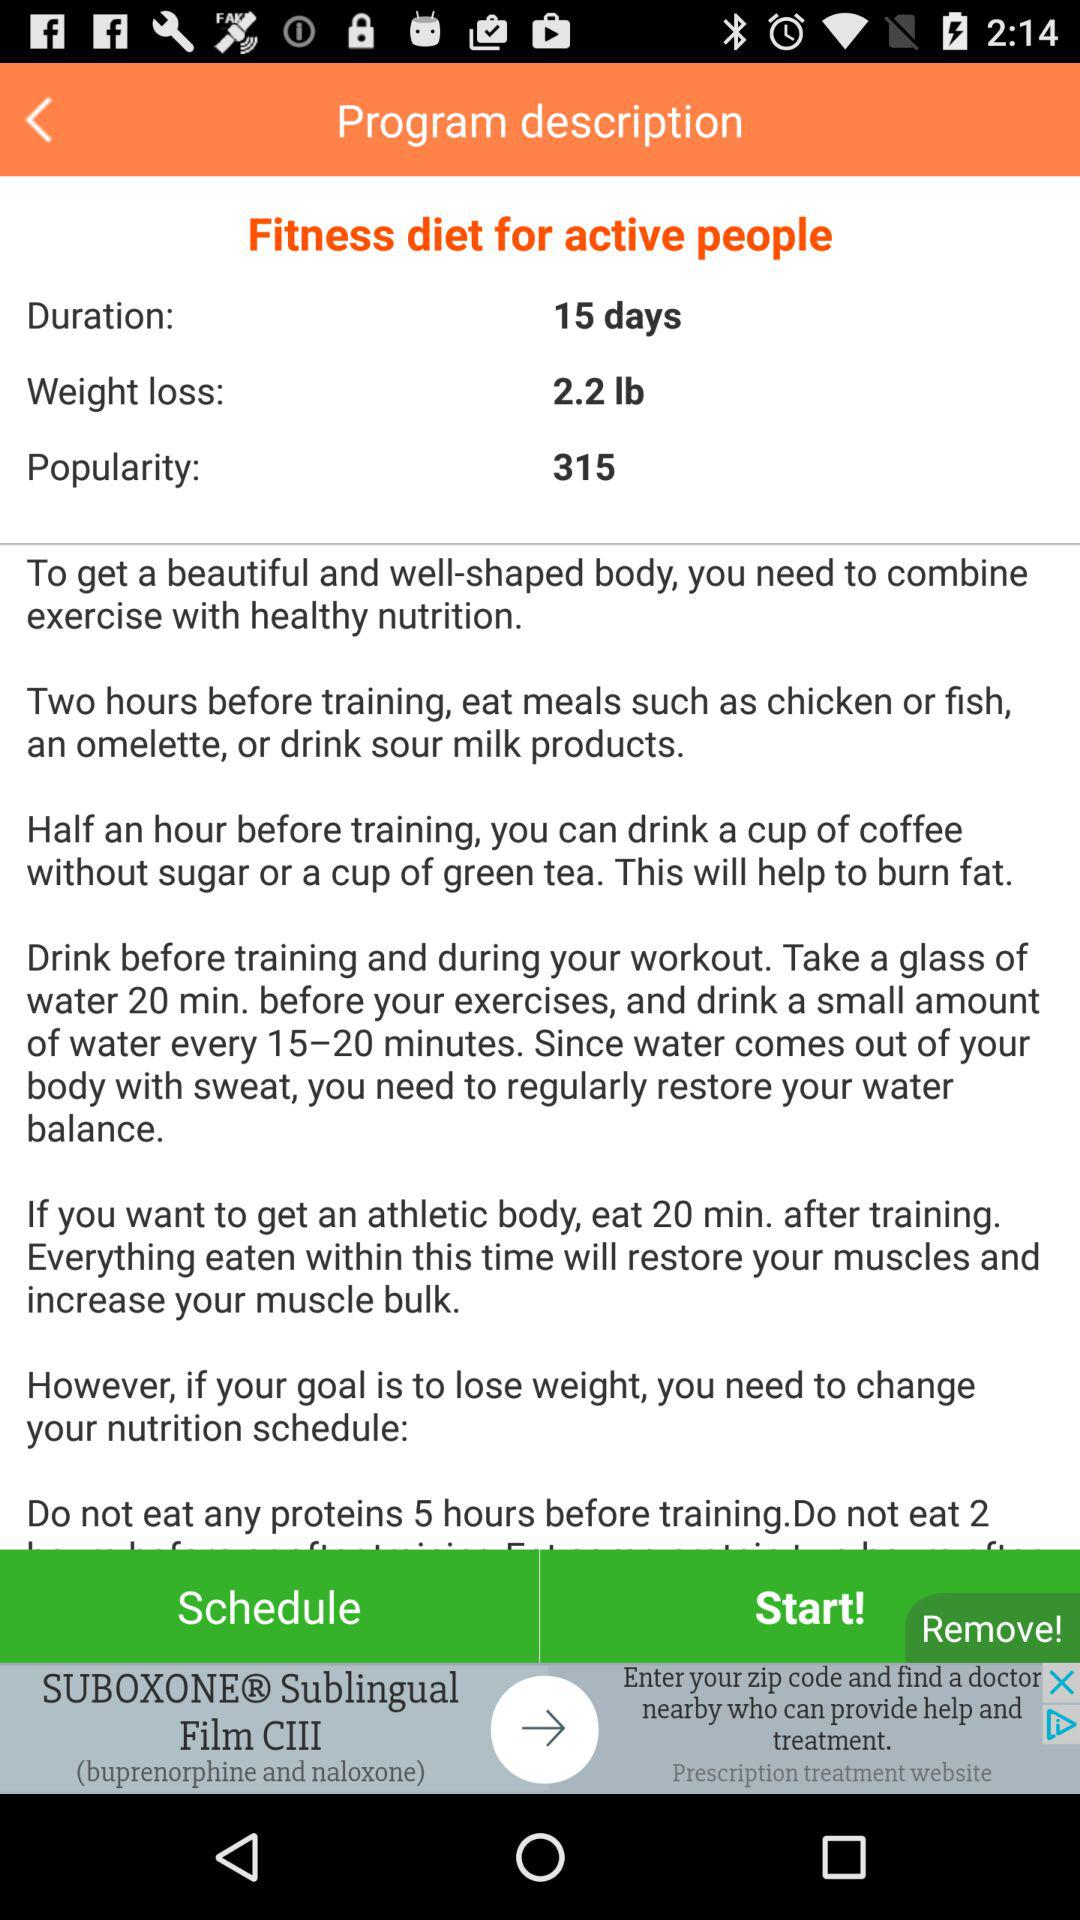What is the value for weight loss? The value for weight loss is 2.2 lbs. 